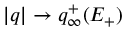Convert formula to latex. <formula><loc_0><loc_0><loc_500><loc_500>| q | \to q _ { \infty } ^ { + } ( E _ { + } )</formula> 